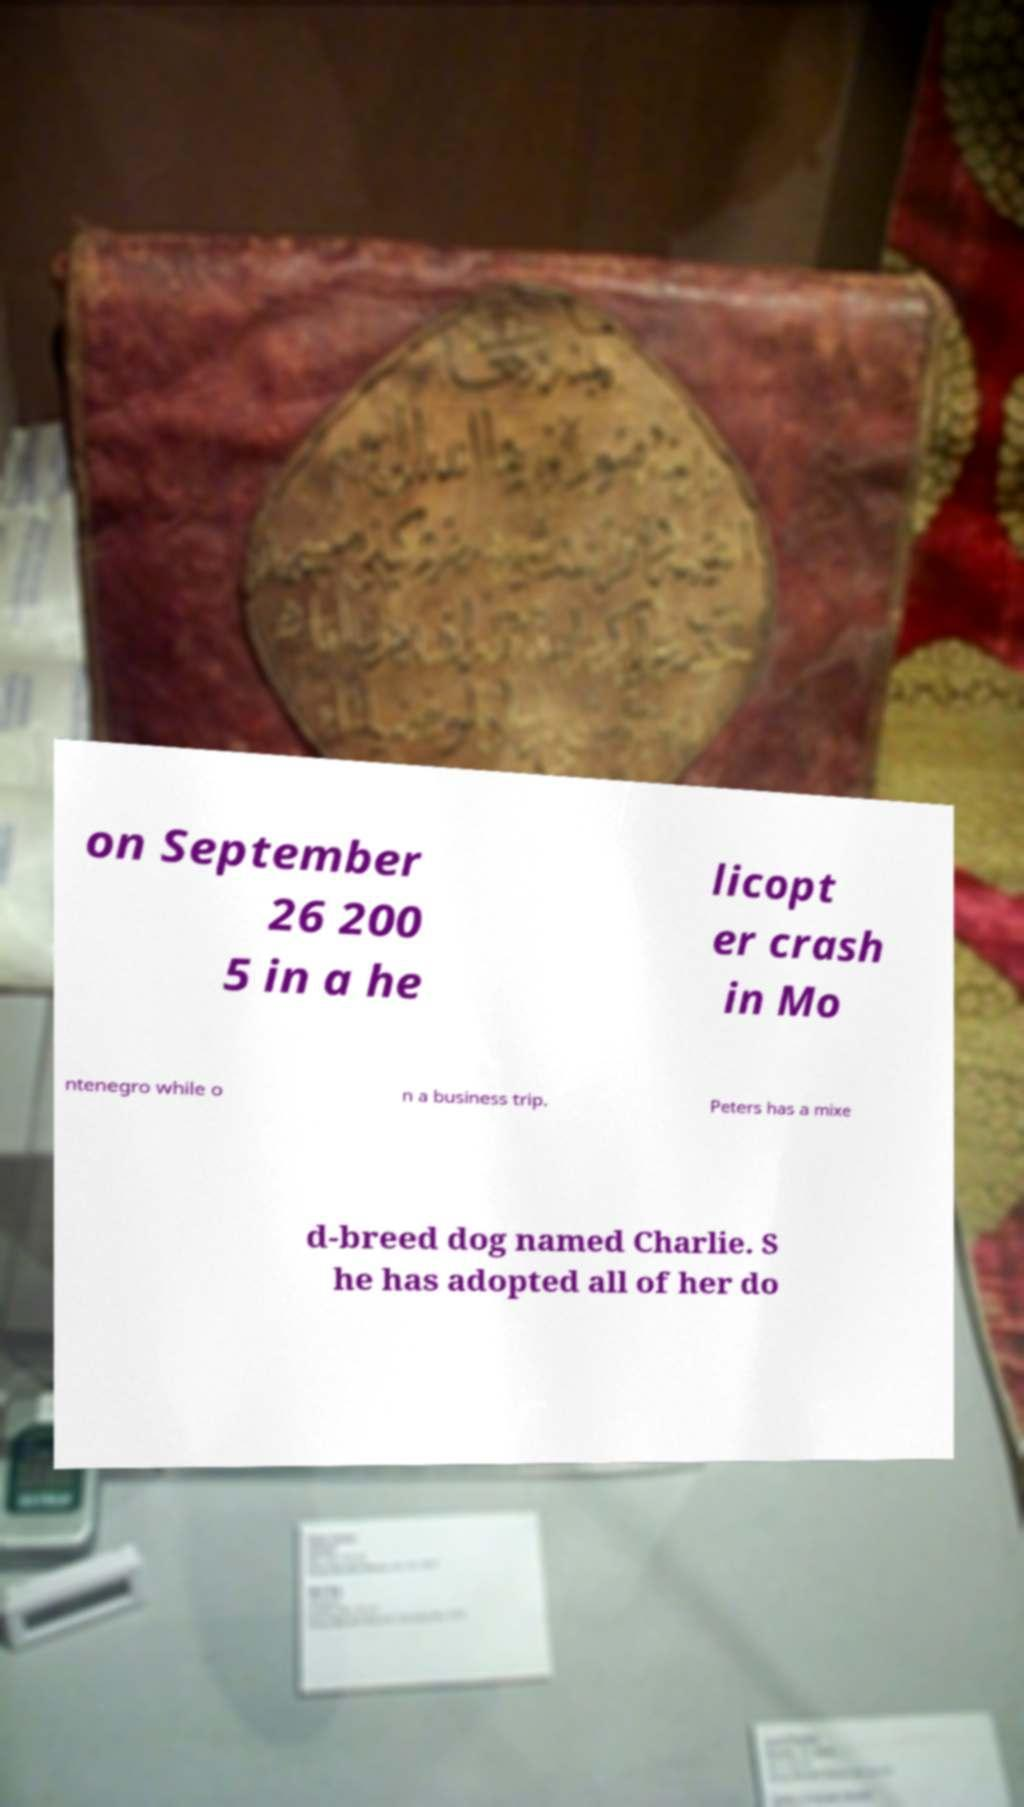Could you extract and type out the text from this image? on September 26 200 5 in a he licopt er crash in Mo ntenegro while o n a business trip. Peters has a mixe d-breed dog named Charlie. S he has adopted all of her do 